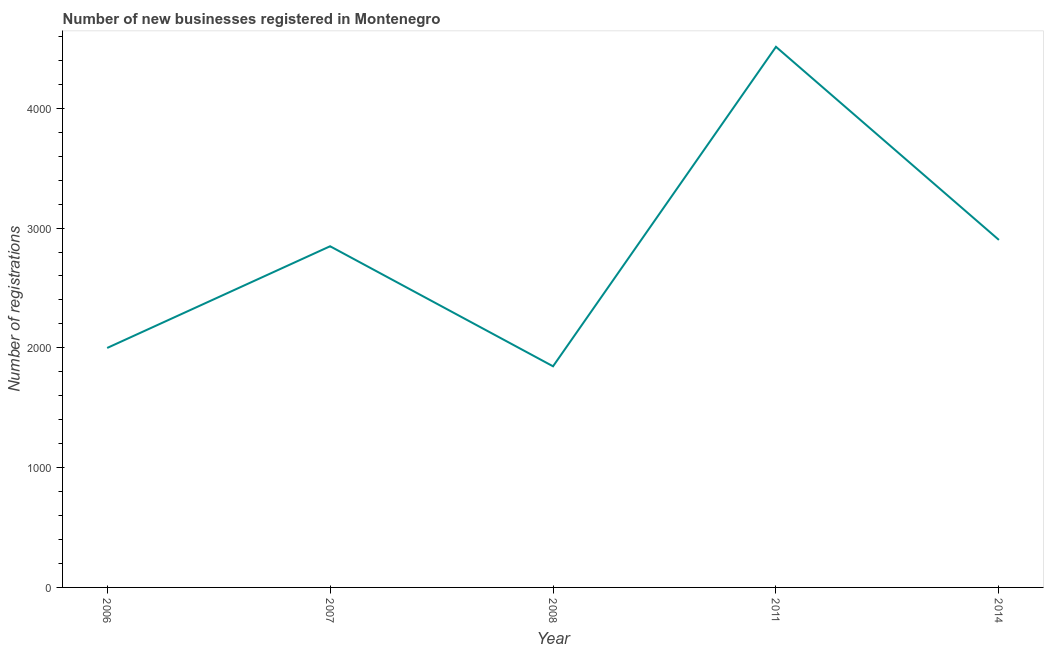What is the number of new business registrations in 2014?
Make the answer very short. 2901. Across all years, what is the maximum number of new business registrations?
Your answer should be compact. 4513. Across all years, what is the minimum number of new business registrations?
Provide a succinct answer. 1846. In which year was the number of new business registrations minimum?
Your answer should be compact. 2008. What is the sum of the number of new business registrations?
Ensure brevity in your answer.  1.41e+04. What is the difference between the number of new business registrations in 2011 and 2014?
Provide a succinct answer. 1612. What is the average number of new business registrations per year?
Your answer should be compact. 2821.4. What is the median number of new business registrations?
Provide a short and direct response. 2848. In how many years, is the number of new business registrations greater than 3800 ?
Make the answer very short. 1. What is the ratio of the number of new business registrations in 2006 to that in 2011?
Offer a terse response. 0.44. Is the difference between the number of new business registrations in 2007 and 2011 greater than the difference between any two years?
Offer a terse response. No. What is the difference between the highest and the second highest number of new business registrations?
Your response must be concise. 1612. Is the sum of the number of new business registrations in 2006 and 2011 greater than the maximum number of new business registrations across all years?
Give a very brief answer. Yes. What is the difference between the highest and the lowest number of new business registrations?
Ensure brevity in your answer.  2667. In how many years, is the number of new business registrations greater than the average number of new business registrations taken over all years?
Offer a terse response. 3. What is the difference between two consecutive major ticks on the Y-axis?
Keep it short and to the point. 1000. Are the values on the major ticks of Y-axis written in scientific E-notation?
Make the answer very short. No. Does the graph contain any zero values?
Ensure brevity in your answer.  No. What is the title of the graph?
Your response must be concise. Number of new businesses registered in Montenegro. What is the label or title of the X-axis?
Your answer should be very brief. Year. What is the label or title of the Y-axis?
Provide a succinct answer. Number of registrations. What is the Number of registrations of 2006?
Provide a short and direct response. 1999. What is the Number of registrations of 2007?
Offer a very short reply. 2848. What is the Number of registrations in 2008?
Make the answer very short. 1846. What is the Number of registrations of 2011?
Keep it short and to the point. 4513. What is the Number of registrations in 2014?
Your answer should be very brief. 2901. What is the difference between the Number of registrations in 2006 and 2007?
Keep it short and to the point. -849. What is the difference between the Number of registrations in 2006 and 2008?
Offer a terse response. 153. What is the difference between the Number of registrations in 2006 and 2011?
Ensure brevity in your answer.  -2514. What is the difference between the Number of registrations in 2006 and 2014?
Your answer should be very brief. -902. What is the difference between the Number of registrations in 2007 and 2008?
Provide a short and direct response. 1002. What is the difference between the Number of registrations in 2007 and 2011?
Offer a very short reply. -1665. What is the difference between the Number of registrations in 2007 and 2014?
Your answer should be very brief. -53. What is the difference between the Number of registrations in 2008 and 2011?
Provide a succinct answer. -2667. What is the difference between the Number of registrations in 2008 and 2014?
Make the answer very short. -1055. What is the difference between the Number of registrations in 2011 and 2014?
Your answer should be very brief. 1612. What is the ratio of the Number of registrations in 2006 to that in 2007?
Make the answer very short. 0.7. What is the ratio of the Number of registrations in 2006 to that in 2008?
Give a very brief answer. 1.08. What is the ratio of the Number of registrations in 2006 to that in 2011?
Your answer should be compact. 0.44. What is the ratio of the Number of registrations in 2006 to that in 2014?
Provide a succinct answer. 0.69. What is the ratio of the Number of registrations in 2007 to that in 2008?
Give a very brief answer. 1.54. What is the ratio of the Number of registrations in 2007 to that in 2011?
Your response must be concise. 0.63. What is the ratio of the Number of registrations in 2007 to that in 2014?
Your answer should be compact. 0.98. What is the ratio of the Number of registrations in 2008 to that in 2011?
Provide a succinct answer. 0.41. What is the ratio of the Number of registrations in 2008 to that in 2014?
Ensure brevity in your answer.  0.64. What is the ratio of the Number of registrations in 2011 to that in 2014?
Offer a terse response. 1.56. 